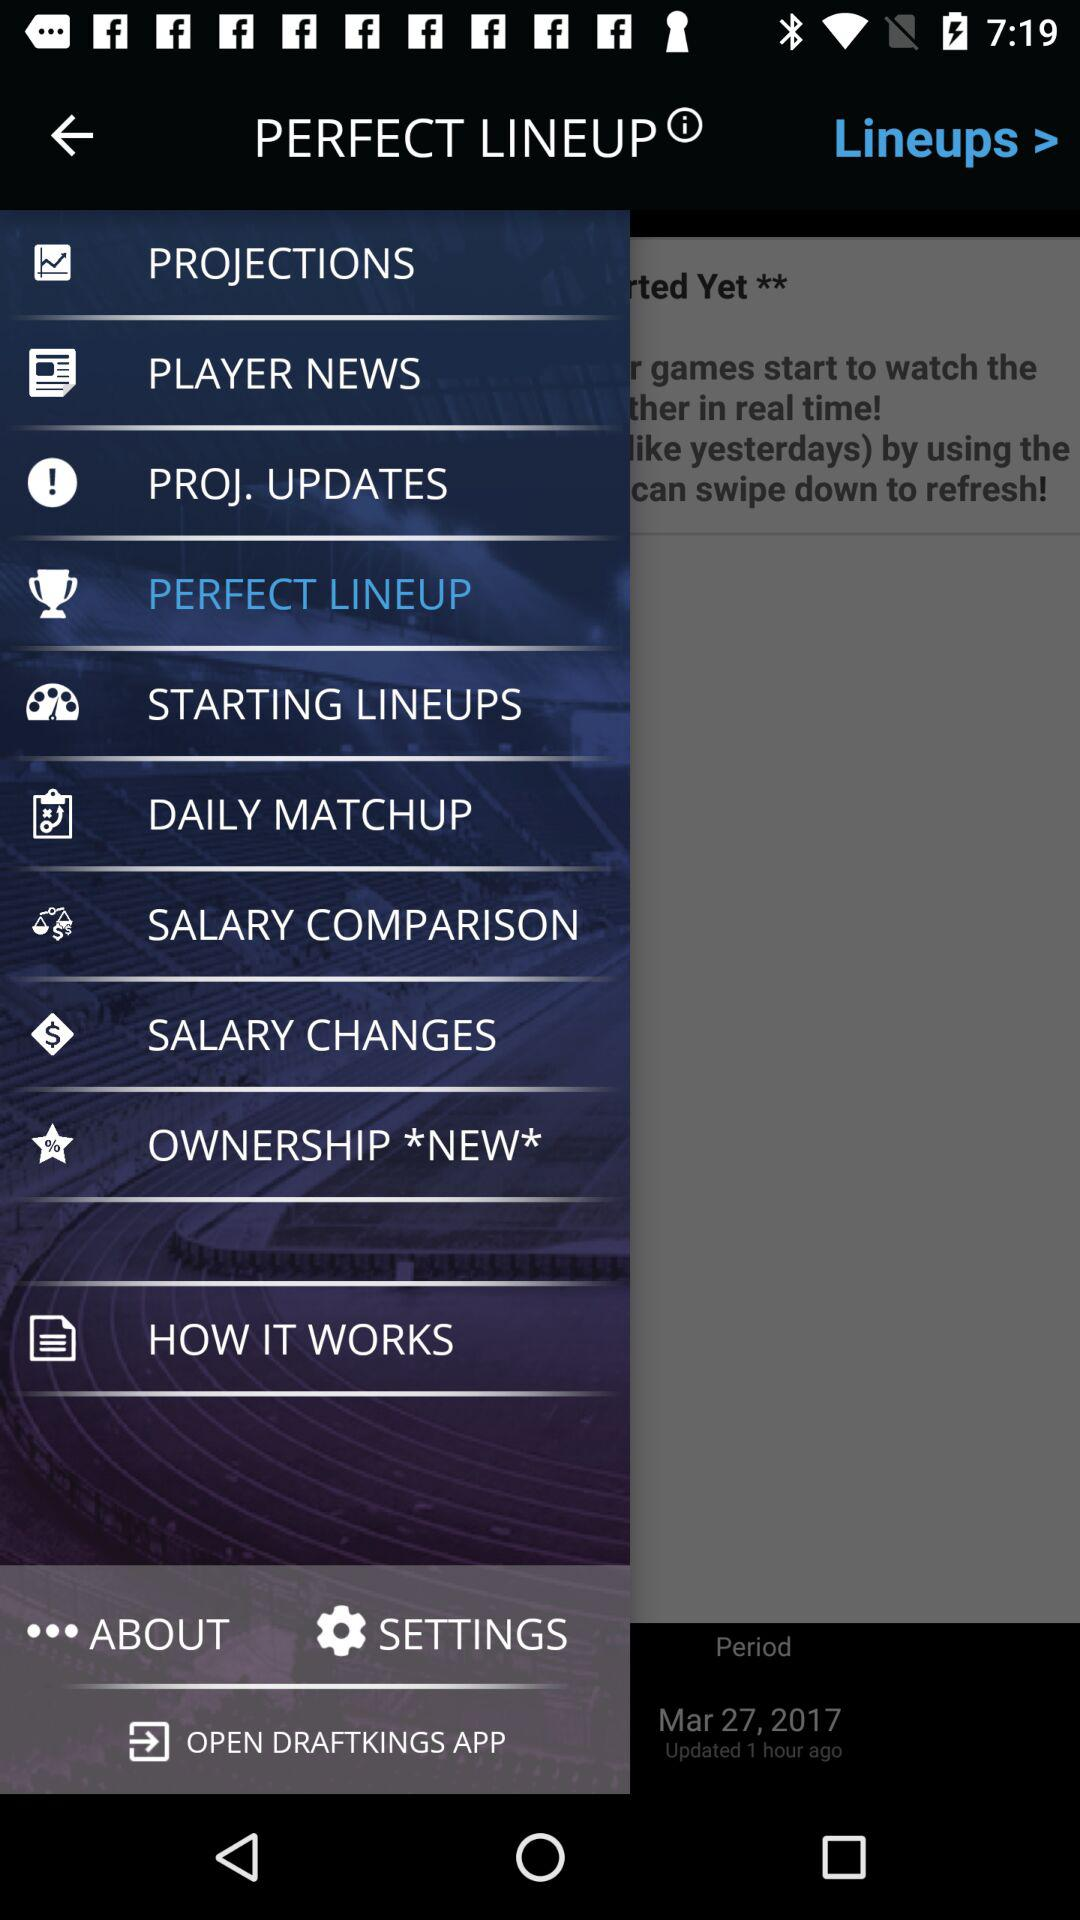How many topics are in "SALARY CHANGES"?
When the provided information is insufficient, respond with <no answer>. <no answer> 